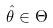<formula> <loc_0><loc_0><loc_500><loc_500>\hat { \theta } \in \Theta</formula> 